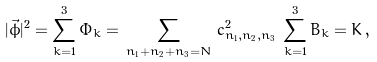Convert formula to latex. <formula><loc_0><loc_0><loc_500><loc_500>| \vec { \phi } | ^ { 2 } = \sum _ { k = 1 } ^ { 3 } \Phi _ { k } = \, \sum _ { n _ { 1 } + n _ { 2 } + n _ { 3 } = N } \, c _ { n _ { 1 } , n _ { 2 } , n _ { 3 } } ^ { 2 } \, \sum _ { k = 1 } ^ { 3 } B _ { k } = K \, ,</formula> 